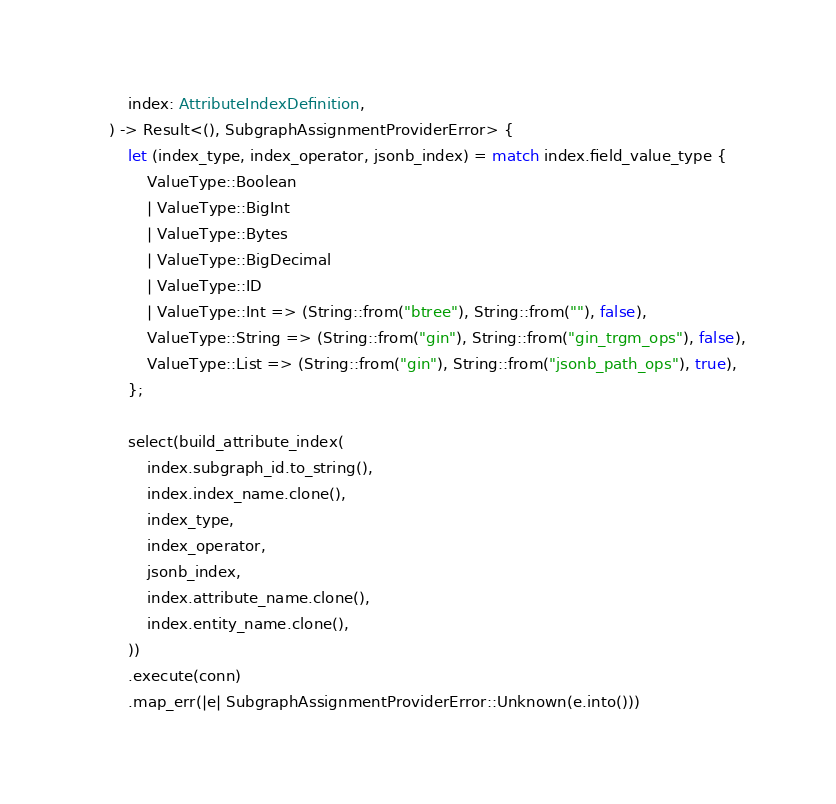Convert code to text. <code><loc_0><loc_0><loc_500><loc_500><_Rust_>        index: AttributeIndexDefinition,
    ) -> Result<(), SubgraphAssignmentProviderError> {
        let (index_type, index_operator, jsonb_index) = match index.field_value_type {
            ValueType::Boolean
            | ValueType::BigInt
            | ValueType::Bytes
            | ValueType::BigDecimal
            | ValueType::ID
            | ValueType::Int => (String::from("btree"), String::from(""), false),
            ValueType::String => (String::from("gin"), String::from("gin_trgm_ops"), false),
            ValueType::List => (String::from("gin"), String::from("jsonb_path_ops"), true),
        };

        select(build_attribute_index(
            index.subgraph_id.to_string(),
            index.index_name.clone(),
            index_type,
            index_operator,
            jsonb_index,
            index.attribute_name.clone(),
            index.entity_name.clone(),
        ))
        .execute(conn)
        .map_err(|e| SubgraphAssignmentProviderError::Unknown(e.into()))</code> 